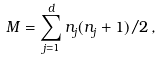Convert formula to latex. <formula><loc_0><loc_0><loc_500><loc_500>M = \sum _ { j = 1 } ^ { d } n _ { j } ( n _ { j } + 1 ) / 2 \, ,</formula> 